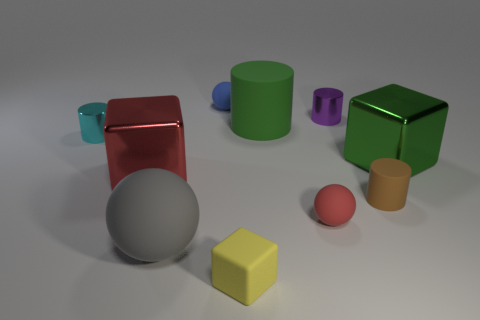Subtract all purple cylinders. How many cylinders are left? 3 Subtract 3 cylinders. How many cylinders are left? 1 Subtract all blue spheres. How many spheres are left? 2 Subtract all brown spheres. Subtract all blue cylinders. How many spheres are left? 3 Subtract all green cylinders. How many red cubes are left? 1 Subtract all brown rubber cylinders. Subtract all blue metallic cylinders. How many objects are left? 9 Add 6 small red matte spheres. How many small red matte spheres are left? 7 Add 6 blue matte balls. How many blue matte balls exist? 7 Subtract 1 red spheres. How many objects are left? 9 Subtract all balls. How many objects are left? 7 